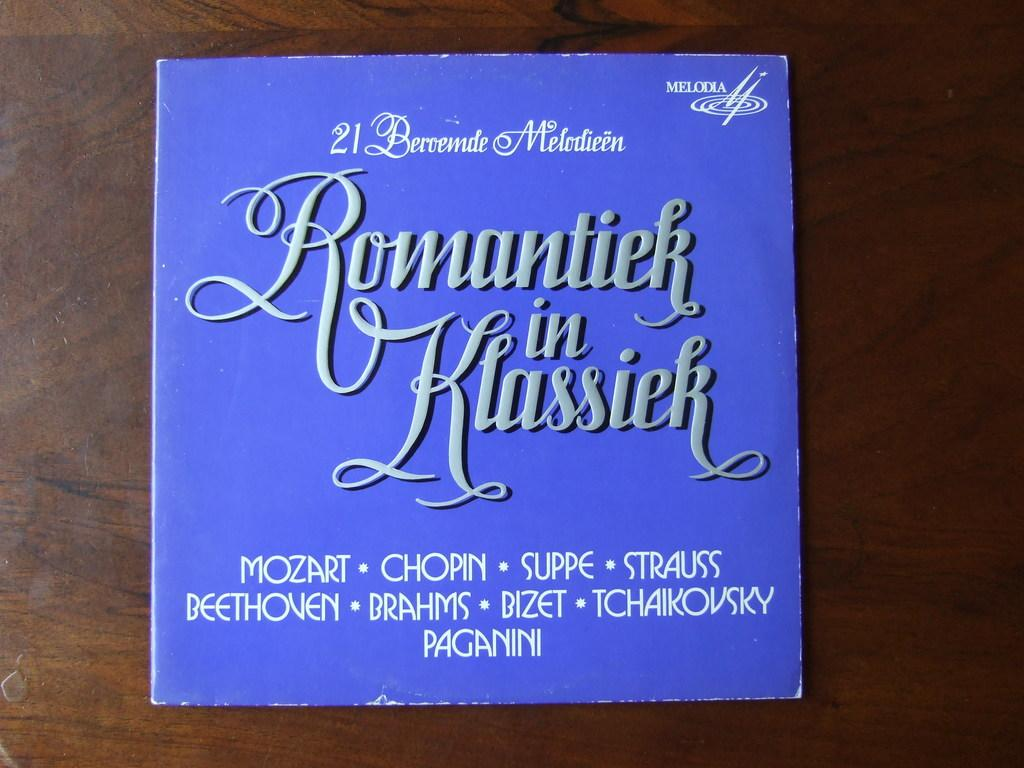<image>
Provide a brief description of the given image. A blue album cover lists some composer names, including Mozart and Chopin. 